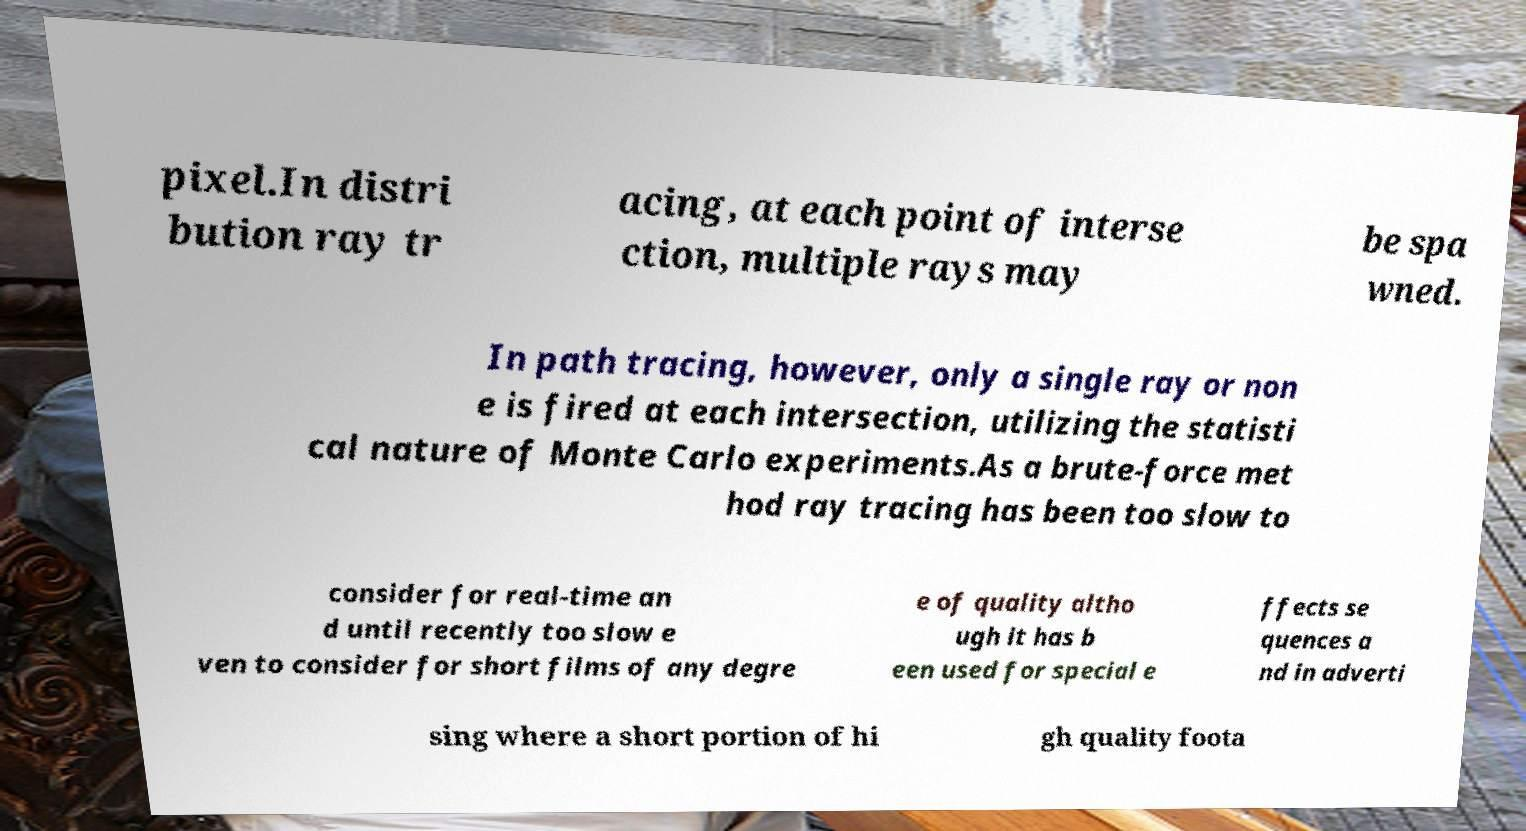For documentation purposes, I need the text within this image transcribed. Could you provide that? pixel.In distri bution ray tr acing, at each point of interse ction, multiple rays may be spa wned. In path tracing, however, only a single ray or non e is fired at each intersection, utilizing the statisti cal nature of Monte Carlo experiments.As a brute-force met hod ray tracing has been too slow to consider for real-time an d until recently too slow e ven to consider for short films of any degre e of quality altho ugh it has b een used for special e ffects se quences a nd in adverti sing where a short portion of hi gh quality foota 